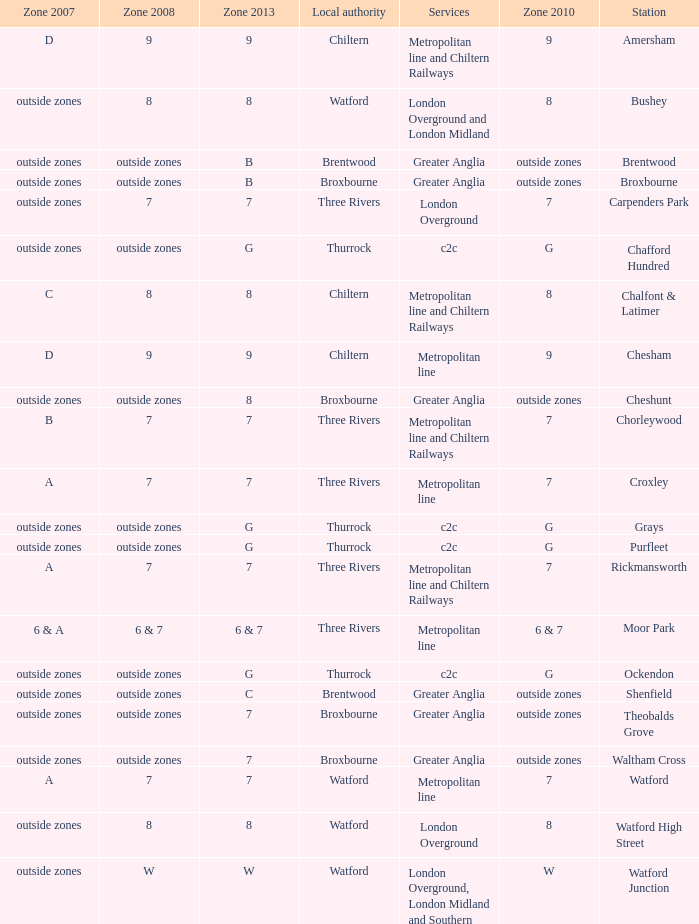Which Services have a Local authority of chiltern, and a Zone 2010 of 9? Metropolitan line and Chiltern Railways, Metropolitan line. 